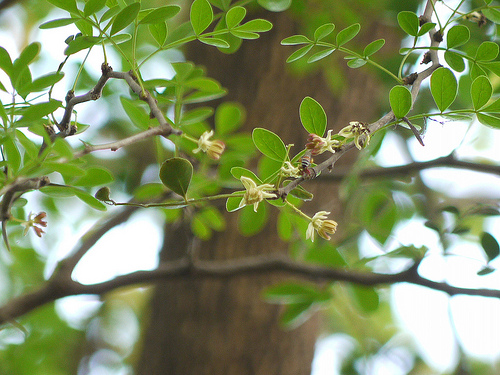<image>
Is there a tree in front of the plant? No. The tree is not in front of the plant. The spatial positioning shows a different relationship between these objects. 